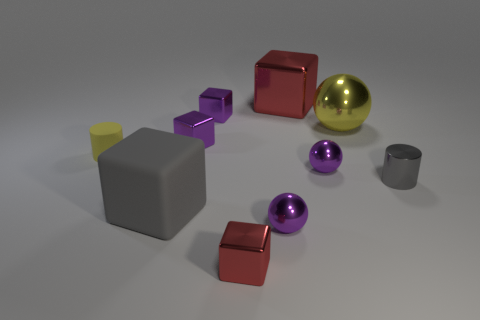How many gray things are either small matte cylinders or cylinders? In the image, we see a collection of various geometric shapes with different colors and finishes. Among them, there is only one object that meets the criteria of being a gray cylinder, which is the small gray matte cylinder at the front right side of the image. 